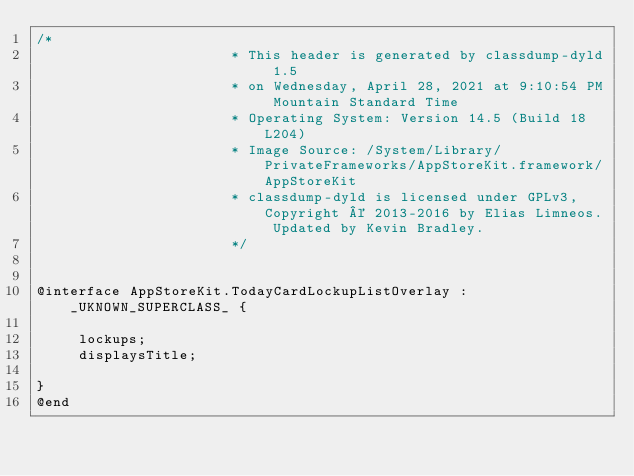<code> <loc_0><loc_0><loc_500><loc_500><_C_>/*
                       * This header is generated by classdump-dyld 1.5
                       * on Wednesday, April 28, 2021 at 9:10:54 PM Mountain Standard Time
                       * Operating System: Version 14.5 (Build 18L204)
                       * Image Source: /System/Library/PrivateFrameworks/AppStoreKit.framework/AppStoreKit
                       * classdump-dyld is licensed under GPLv3, Copyright © 2013-2016 by Elias Limneos. Updated by Kevin Bradley.
                       */


@interface AppStoreKit.TodayCardLockupListOverlay : _UKNOWN_SUPERCLASS_ {

	 lockups;
	 displaysTitle;

}
@end

</code> 